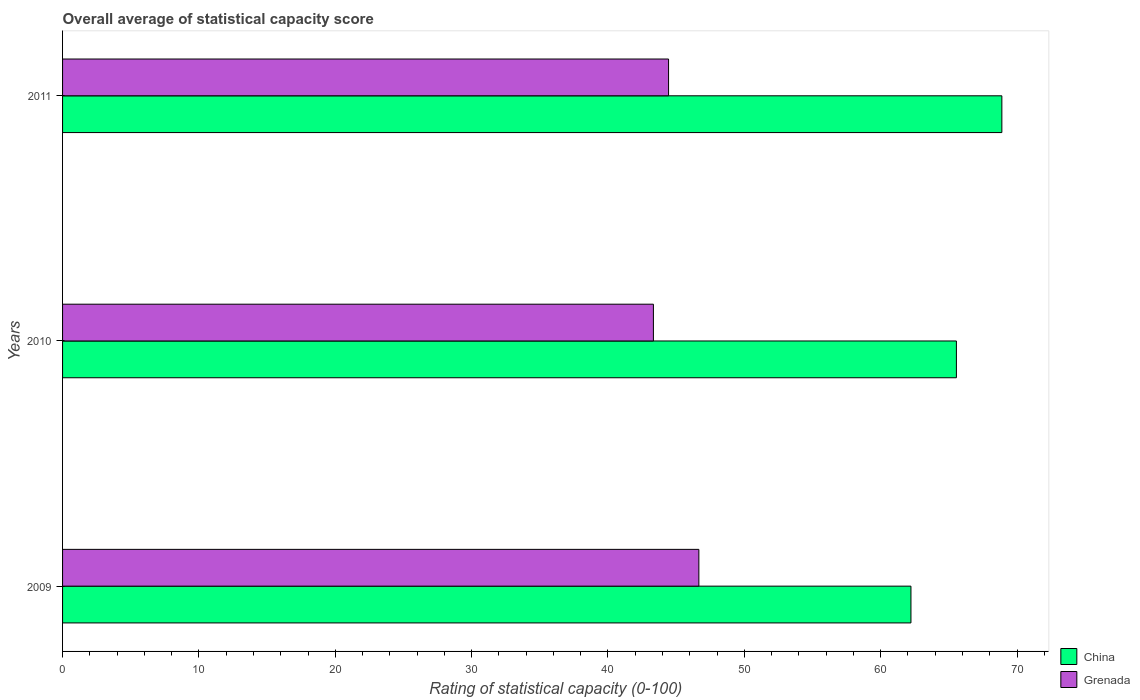Are the number of bars on each tick of the Y-axis equal?
Your answer should be compact. Yes. How many bars are there on the 1st tick from the top?
Provide a succinct answer. 2. How many bars are there on the 3rd tick from the bottom?
Keep it short and to the point. 2. What is the label of the 1st group of bars from the top?
Your answer should be very brief. 2011. In how many cases, is the number of bars for a given year not equal to the number of legend labels?
Give a very brief answer. 0. What is the rating of statistical capacity in Grenada in 2009?
Ensure brevity in your answer.  46.67. Across all years, what is the maximum rating of statistical capacity in Grenada?
Keep it short and to the point. 46.67. Across all years, what is the minimum rating of statistical capacity in China?
Keep it short and to the point. 62.22. In which year was the rating of statistical capacity in Grenada maximum?
Your response must be concise. 2009. What is the total rating of statistical capacity in Grenada in the graph?
Provide a short and direct response. 134.44. What is the difference between the rating of statistical capacity in Grenada in 2009 and that in 2010?
Give a very brief answer. 3.33. What is the difference between the rating of statistical capacity in China in 2010 and the rating of statistical capacity in Grenada in 2011?
Offer a terse response. 21.11. What is the average rating of statistical capacity in Grenada per year?
Your response must be concise. 44.81. In the year 2009, what is the difference between the rating of statistical capacity in China and rating of statistical capacity in Grenada?
Your answer should be very brief. 15.56. What is the ratio of the rating of statistical capacity in Grenada in 2010 to that in 2011?
Your answer should be compact. 0.98. Is the difference between the rating of statistical capacity in China in 2009 and 2010 greater than the difference between the rating of statistical capacity in Grenada in 2009 and 2010?
Your answer should be very brief. No. What is the difference between the highest and the second highest rating of statistical capacity in Grenada?
Your answer should be very brief. 2.22. What is the difference between the highest and the lowest rating of statistical capacity in Grenada?
Your answer should be very brief. 3.33. Is the sum of the rating of statistical capacity in China in 2009 and 2010 greater than the maximum rating of statistical capacity in Grenada across all years?
Your answer should be compact. Yes. What does the 1st bar from the top in 2011 represents?
Your response must be concise. Grenada. What does the 2nd bar from the bottom in 2011 represents?
Keep it short and to the point. Grenada. Are all the bars in the graph horizontal?
Keep it short and to the point. Yes. What is the difference between two consecutive major ticks on the X-axis?
Provide a succinct answer. 10. Are the values on the major ticks of X-axis written in scientific E-notation?
Your answer should be compact. No. Does the graph contain any zero values?
Your response must be concise. No. Does the graph contain grids?
Keep it short and to the point. No. What is the title of the graph?
Provide a succinct answer. Overall average of statistical capacity score. What is the label or title of the X-axis?
Offer a very short reply. Rating of statistical capacity (0-100). What is the Rating of statistical capacity (0-100) of China in 2009?
Your answer should be compact. 62.22. What is the Rating of statistical capacity (0-100) in Grenada in 2009?
Your response must be concise. 46.67. What is the Rating of statistical capacity (0-100) in China in 2010?
Your answer should be very brief. 65.56. What is the Rating of statistical capacity (0-100) in Grenada in 2010?
Your answer should be compact. 43.33. What is the Rating of statistical capacity (0-100) of China in 2011?
Ensure brevity in your answer.  68.89. What is the Rating of statistical capacity (0-100) of Grenada in 2011?
Provide a succinct answer. 44.44. Across all years, what is the maximum Rating of statistical capacity (0-100) of China?
Offer a terse response. 68.89. Across all years, what is the maximum Rating of statistical capacity (0-100) of Grenada?
Keep it short and to the point. 46.67. Across all years, what is the minimum Rating of statistical capacity (0-100) in China?
Ensure brevity in your answer.  62.22. Across all years, what is the minimum Rating of statistical capacity (0-100) of Grenada?
Your answer should be compact. 43.33. What is the total Rating of statistical capacity (0-100) of China in the graph?
Your response must be concise. 196.67. What is the total Rating of statistical capacity (0-100) in Grenada in the graph?
Give a very brief answer. 134.44. What is the difference between the Rating of statistical capacity (0-100) in Grenada in 2009 and that in 2010?
Make the answer very short. 3.33. What is the difference between the Rating of statistical capacity (0-100) of China in 2009 and that in 2011?
Give a very brief answer. -6.67. What is the difference between the Rating of statistical capacity (0-100) in Grenada in 2009 and that in 2011?
Your answer should be compact. 2.22. What is the difference between the Rating of statistical capacity (0-100) in Grenada in 2010 and that in 2011?
Give a very brief answer. -1.11. What is the difference between the Rating of statistical capacity (0-100) of China in 2009 and the Rating of statistical capacity (0-100) of Grenada in 2010?
Offer a terse response. 18.89. What is the difference between the Rating of statistical capacity (0-100) in China in 2009 and the Rating of statistical capacity (0-100) in Grenada in 2011?
Offer a terse response. 17.78. What is the difference between the Rating of statistical capacity (0-100) in China in 2010 and the Rating of statistical capacity (0-100) in Grenada in 2011?
Your response must be concise. 21.11. What is the average Rating of statistical capacity (0-100) in China per year?
Keep it short and to the point. 65.56. What is the average Rating of statistical capacity (0-100) in Grenada per year?
Your answer should be compact. 44.81. In the year 2009, what is the difference between the Rating of statistical capacity (0-100) of China and Rating of statistical capacity (0-100) of Grenada?
Offer a terse response. 15.56. In the year 2010, what is the difference between the Rating of statistical capacity (0-100) in China and Rating of statistical capacity (0-100) in Grenada?
Offer a terse response. 22.22. In the year 2011, what is the difference between the Rating of statistical capacity (0-100) of China and Rating of statistical capacity (0-100) of Grenada?
Offer a very short reply. 24.44. What is the ratio of the Rating of statistical capacity (0-100) in China in 2009 to that in 2010?
Provide a succinct answer. 0.95. What is the ratio of the Rating of statistical capacity (0-100) in Grenada in 2009 to that in 2010?
Ensure brevity in your answer.  1.08. What is the ratio of the Rating of statistical capacity (0-100) of China in 2009 to that in 2011?
Provide a succinct answer. 0.9. What is the ratio of the Rating of statistical capacity (0-100) in China in 2010 to that in 2011?
Offer a very short reply. 0.95. What is the ratio of the Rating of statistical capacity (0-100) of Grenada in 2010 to that in 2011?
Provide a short and direct response. 0.97. What is the difference between the highest and the second highest Rating of statistical capacity (0-100) in Grenada?
Offer a terse response. 2.22. What is the difference between the highest and the lowest Rating of statistical capacity (0-100) of China?
Your response must be concise. 6.67. 